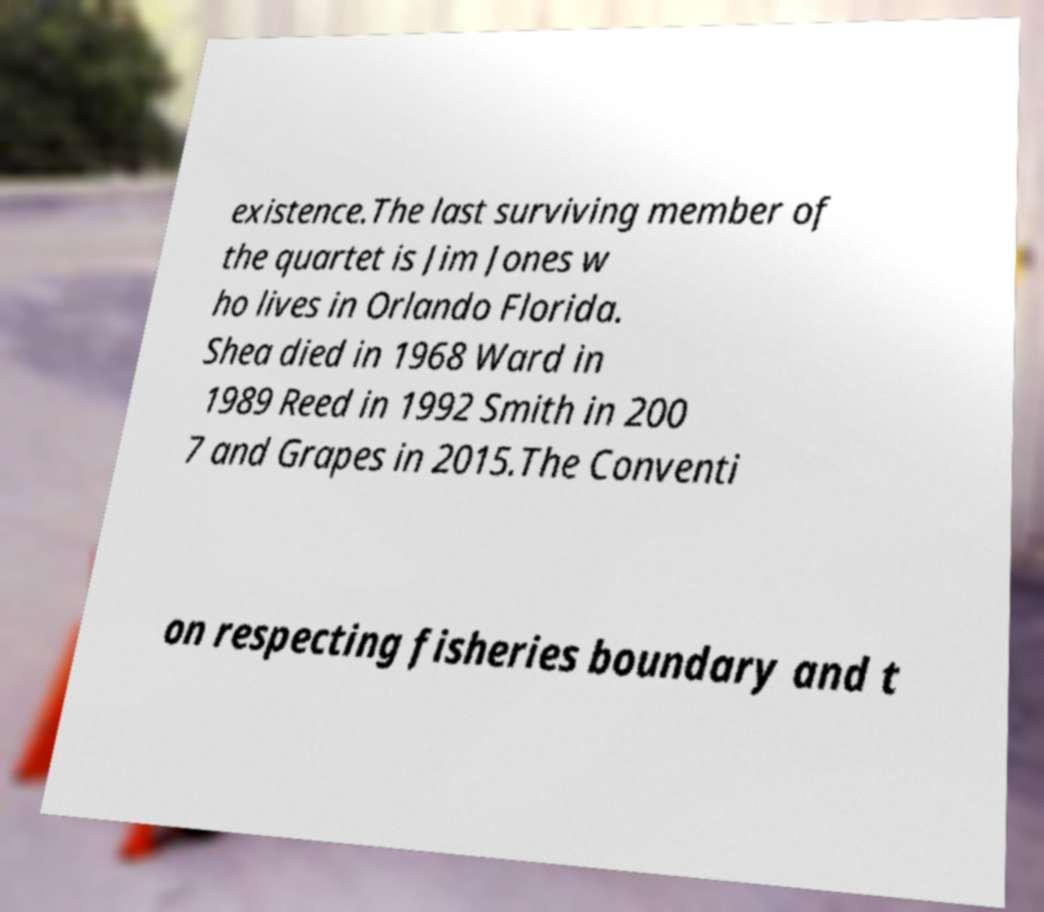Could you extract and type out the text from this image? existence.The last surviving member of the quartet is Jim Jones w ho lives in Orlando Florida. Shea died in 1968 Ward in 1989 Reed in 1992 Smith in 200 7 and Grapes in 2015.The Conventi on respecting fisheries boundary and t 